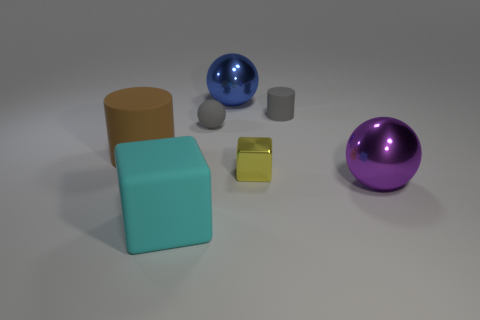Add 1 big brown matte objects. How many objects exist? 8 Subtract all blocks. How many objects are left? 5 Subtract 0 yellow cylinders. How many objects are left? 7 Subtract all tiny metallic objects. Subtract all big cyan blocks. How many objects are left? 5 Add 1 small yellow shiny blocks. How many small yellow shiny blocks are left? 2 Add 4 cubes. How many cubes exist? 6 